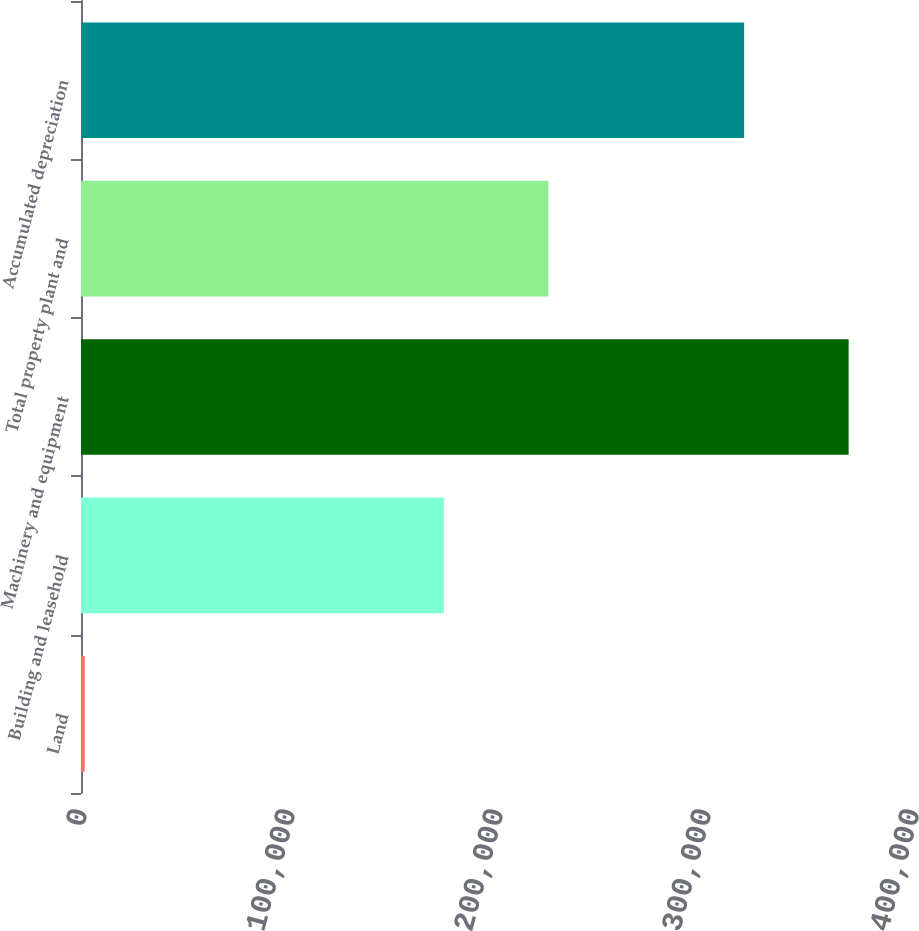Convert chart to OTSL. <chart><loc_0><loc_0><loc_500><loc_500><bar_chart><fcel>Land<fcel>Building and leasehold<fcel>Machinery and equipment<fcel>Total property plant and<fcel>Accumulated depreciation<nl><fcel>1779<fcel>174449<fcel>369052<fcel>224690<fcel>318811<nl></chart> 